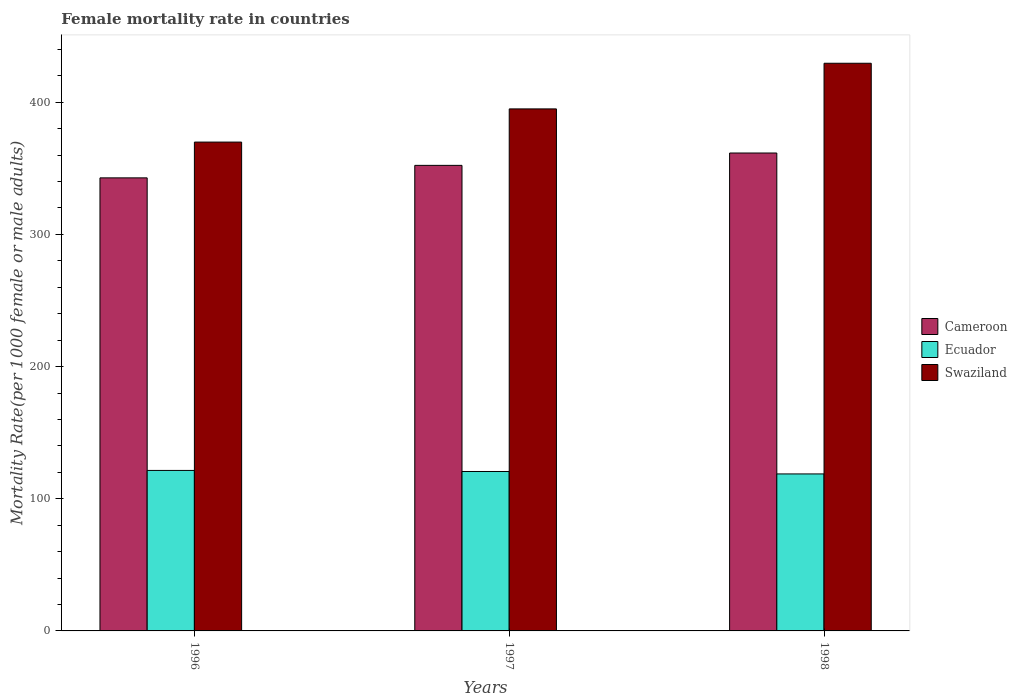How many different coloured bars are there?
Make the answer very short. 3. How many groups of bars are there?
Make the answer very short. 3. Are the number of bars on each tick of the X-axis equal?
Provide a succinct answer. Yes. How many bars are there on the 3rd tick from the left?
Your answer should be compact. 3. What is the female mortality rate in Cameroon in 1998?
Your answer should be very brief. 361.56. Across all years, what is the maximum female mortality rate in Swaziland?
Your response must be concise. 429.47. Across all years, what is the minimum female mortality rate in Cameroon?
Give a very brief answer. 342.77. In which year was the female mortality rate in Cameroon maximum?
Provide a succinct answer. 1998. What is the total female mortality rate in Swaziland in the graph?
Offer a terse response. 1194.25. What is the difference between the female mortality rate in Cameroon in 1997 and that in 1998?
Your answer should be compact. -9.35. What is the difference between the female mortality rate in Cameroon in 1997 and the female mortality rate in Swaziland in 1996?
Your answer should be compact. -17.62. What is the average female mortality rate in Ecuador per year?
Your answer should be very brief. 120.27. In the year 1998, what is the difference between the female mortality rate in Swaziland and female mortality rate in Ecuador?
Your response must be concise. 310.7. What is the ratio of the female mortality rate in Cameroon in 1996 to that in 1998?
Give a very brief answer. 0.95. Is the female mortality rate in Cameroon in 1996 less than that in 1997?
Offer a terse response. Yes. Is the difference between the female mortality rate in Swaziland in 1996 and 1998 greater than the difference between the female mortality rate in Ecuador in 1996 and 1998?
Offer a very short reply. No. What is the difference between the highest and the second highest female mortality rate in Swaziland?
Provide a short and direct response. 34.53. What is the difference between the highest and the lowest female mortality rate in Cameroon?
Your answer should be very brief. 18.8. In how many years, is the female mortality rate in Cameroon greater than the average female mortality rate in Cameroon taken over all years?
Make the answer very short. 2. What does the 1st bar from the left in 1998 represents?
Your answer should be very brief. Cameroon. What does the 1st bar from the right in 1998 represents?
Offer a very short reply. Swaziland. How many bars are there?
Your answer should be very brief. 9. Are all the bars in the graph horizontal?
Your answer should be compact. No. How many years are there in the graph?
Keep it short and to the point. 3. Does the graph contain any zero values?
Provide a short and direct response. No. Where does the legend appear in the graph?
Offer a terse response. Center right. How many legend labels are there?
Give a very brief answer. 3. What is the title of the graph?
Provide a short and direct response. Female mortality rate in countries. What is the label or title of the X-axis?
Ensure brevity in your answer.  Years. What is the label or title of the Y-axis?
Keep it short and to the point. Mortality Rate(per 1000 female or male adults). What is the Mortality Rate(per 1000 female or male adults) of Cameroon in 1996?
Your response must be concise. 342.77. What is the Mortality Rate(per 1000 female or male adults) of Ecuador in 1996?
Offer a terse response. 121.42. What is the Mortality Rate(per 1000 female or male adults) of Swaziland in 1996?
Provide a short and direct response. 369.84. What is the Mortality Rate(per 1000 female or male adults) of Cameroon in 1997?
Make the answer very short. 352.22. What is the Mortality Rate(per 1000 female or male adults) in Ecuador in 1997?
Give a very brief answer. 120.62. What is the Mortality Rate(per 1000 female or male adults) of Swaziland in 1997?
Give a very brief answer. 394.94. What is the Mortality Rate(per 1000 female or male adults) of Cameroon in 1998?
Your answer should be compact. 361.56. What is the Mortality Rate(per 1000 female or male adults) in Ecuador in 1998?
Your answer should be very brief. 118.77. What is the Mortality Rate(per 1000 female or male adults) of Swaziland in 1998?
Provide a short and direct response. 429.47. Across all years, what is the maximum Mortality Rate(per 1000 female or male adults) in Cameroon?
Keep it short and to the point. 361.56. Across all years, what is the maximum Mortality Rate(per 1000 female or male adults) of Ecuador?
Offer a terse response. 121.42. Across all years, what is the maximum Mortality Rate(per 1000 female or male adults) in Swaziland?
Provide a succinct answer. 429.47. Across all years, what is the minimum Mortality Rate(per 1000 female or male adults) in Cameroon?
Keep it short and to the point. 342.77. Across all years, what is the minimum Mortality Rate(per 1000 female or male adults) in Ecuador?
Your answer should be compact. 118.77. Across all years, what is the minimum Mortality Rate(per 1000 female or male adults) of Swaziland?
Keep it short and to the point. 369.84. What is the total Mortality Rate(per 1000 female or male adults) in Cameroon in the graph?
Give a very brief answer. 1056.55. What is the total Mortality Rate(per 1000 female or male adults) of Ecuador in the graph?
Your answer should be very brief. 360.81. What is the total Mortality Rate(per 1000 female or male adults) of Swaziland in the graph?
Keep it short and to the point. 1194.25. What is the difference between the Mortality Rate(per 1000 female or male adults) of Cameroon in 1996 and that in 1997?
Provide a succinct answer. -9.45. What is the difference between the Mortality Rate(per 1000 female or male adults) of Ecuador in 1996 and that in 1997?
Your answer should be compact. 0.8. What is the difference between the Mortality Rate(per 1000 female or male adults) of Swaziland in 1996 and that in 1997?
Your answer should be compact. -25.1. What is the difference between the Mortality Rate(per 1000 female or male adults) in Cameroon in 1996 and that in 1998?
Provide a short and direct response. -18.8. What is the difference between the Mortality Rate(per 1000 female or male adults) in Ecuador in 1996 and that in 1998?
Give a very brief answer. 2.65. What is the difference between the Mortality Rate(per 1000 female or male adults) in Swaziland in 1996 and that in 1998?
Keep it short and to the point. -59.63. What is the difference between the Mortality Rate(per 1000 female or male adults) of Cameroon in 1997 and that in 1998?
Provide a succinct answer. -9.35. What is the difference between the Mortality Rate(per 1000 female or male adults) of Ecuador in 1997 and that in 1998?
Your response must be concise. 1.85. What is the difference between the Mortality Rate(per 1000 female or male adults) in Swaziland in 1997 and that in 1998?
Your answer should be very brief. -34.53. What is the difference between the Mortality Rate(per 1000 female or male adults) in Cameroon in 1996 and the Mortality Rate(per 1000 female or male adults) in Ecuador in 1997?
Offer a very short reply. 222.15. What is the difference between the Mortality Rate(per 1000 female or male adults) of Cameroon in 1996 and the Mortality Rate(per 1000 female or male adults) of Swaziland in 1997?
Offer a very short reply. -52.17. What is the difference between the Mortality Rate(per 1000 female or male adults) in Ecuador in 1996 and the Mortality Rate(per 1000 female or male adults) in Swaziland in 1997?
Your response must be concise. -273.52. What is the difference between the Mortality Rate(per 1000 female or male adults) in Cameroon in 1996 and the Mortality Rate(per 1000 female or male adults) in Ecuador in 1998?
Give a very brief answer. 224. What is the difference between the Mortality Rate(per 1000 female or male adults) of Cameroon in 1996 and the Mortality Rate(per 1000 female or male adults) of Swaziland in 1998?
Provide a succinct answer. -86.7. What is the difference between the Mortality Rate(per 1000 female or male adults) in Ecuador in 1996 and the Mortality Rate(per 1000 female or male adults) in Swaziland in 1998?
Your response must be concise. -308.05. What is the difference between the Mortality Rate(per 1000 female or male adults) in Cameroon in 1997 and the Mortality Rate(per 1000 female or male adults) in Ecuador in 1998?
Keep it short and to the point. 233.44. What is the difference between the Mortality Rate(per 1000 female or male adults) in Cameroon in 1997 and the Mortality Rate(per 1000 female or male adults) in Swaziland in 1998?
Your response must be concise. -77.26. What is the difference between the Mortality Rate(per 1000 female or male adults) of Ecuador in 1997 and the Mortality Rate(per 1000 female or male adults) of Swaziland in 1998?
Provide a short and direct response. -308.85. What is the average Mortality Rate(per 1000 female or male adults) of Cameroon per year?
Your answer should be very brief. 352.18. What is the average Mortality Rate(per 1000 female or male adults) in Ecuador per year?
Your answer should be very brief. 120.27. What is the average Mortality Rate(per 1000 female or male adults) of Swaziland per year?
Make the answer very short. 398.08. In the year 1996, what is the difference between the Mortality Rate(per 1000 female or male adults) in Cameroon and Mortality Rate(per 1000 female or male adults) in Ecuador?
Your answer should be compact. 221.35. In the year 1996, what is the difference between the Mortality Rate(per 1000 female or male adults) of Cameroon and Mortality Rate(per 1000 female or male adults) of Swaziland?
Keep it short and to the point. -27.07. In the year 1996, what is the difference between the Mortality Rate(per 1000 female or male adults) of Ecuador and Mortality Rate(per 1000 female or male adults) of Swaziland?
Offer a very short reply. -248.42. In the year 1997, what is the difference between the Mortality Rate(per 1000 female or male adults) of Cameroon and Mortality Rate(per 1000 female or male adults) of Ecuador?
Your response must be concise. 231.6. In the year 1997, what is the difference between the Mortality Rate(per 1000 female or male adults) in Cameroon and Mortality Rate(per 1000 female or male adults) in Swaziland?
Your answer should be compact. -42.72. In the year 1997, what is the difference between the Mortality Rate(per 1000 female or male adults) of Ecuador and Mortality Rate(per 1000 female or male adults) of Swaziland?
Offer a terse response. -274.32. In the year 1998, what is the difference between the Mortality Rate(per 1000 female or male adults) of Cameroon and Mortality Rate(per 1000 female or male adults) of Ecuador?
Your answer should be very brief. 242.79. In the year 1998, what is the difference between the Mortality Rate(per 1000 female or male adults) in Cameroon and Mortality Rate(per 1000 female or male adults) in Swaziland?
Your response must be concise. -67.91. In the year 1998, what is the difference between the Mortality Rate(per 1000 female or male adults) in Ecuador and Mortality Rate(per 1000 female or male adults) in Swaziland?
Keep it short and to the point. -310.7. What is the ratio of the Mortality Rate(per 1000 female or male adults) of Cameroon in 1996 to that in 1997?
Offer a very short reply. 0.97. What is the ratio of the Mortality Rate(per 1000 female or male adults) of Ecuador in 1996 to that in 1997?
Your answer should be very brief. 1.01. What is the ratio of the Mortality Rate(per 1000 female or male adults) of Swaziland in 1996 to that in 1997?
Offer a terse response. 0.94. What is the ratio of the Mortality Rate(per 1000 female or male adults) in Cameroon in 1996 to that in 1998?
Your answer should be compact. 0.95. What is the ratio of the Mortality Rate(per 1000 female or male adults) in Ecuador in 1996 to that in 1998?
Provide a short and direct response. 1.02. What is the ratio of the Mortality Rate(per 1000 female or male adults) of Swaziland in 1996 to that in 1998?
Your response must be concise. 0.86. What is the ratio of the Mortality Rate(per 1000 female or male adults) of Cameroon in 1997 to that in 1998?
Provide a short and direct response. 0.97. What is the ratio of the Mortality Rate(per 1000 female or male adults) of Ecuador in 1997 to that in 1998?
Your answer should be very brief. 1.02. What is the ratio of the Mortality Rate(per 1000 female or male adults) of Swaziland in 1997 to that in 1998?
Keep it short and to the point. 0.92. What is the difference between the highest and the second highest Mortality Rate(per 1000 female or male adults) in Cameroon?
Keep it short and to the point. 9.35. What is the difference between the highest and the second highest Mortality Rate(per 1000 female or male adults) of Ecuador?
Make the answer very short. 0.8. What is the difference between the highest and the second highest Mortality Rate(per 1000 female or male adults) in Swaziland?
Your answer should be very brief. 34.53. What is the difference between the highest and the lowest Mortality Rate(per 1000 female or male adults) in Cameroon?
Give a very brief answer. 18.8. What is the difference between the highest and the lowest Mortality Rate(per 1000 female or male adults) in Ecuador?
Ensure brevity in your answer.  2.65. What is the difference between the highest and the lowest Mortality Rate(per 1000 female or male adults) of Swaziland?
Offer a terse response. 59.63. 